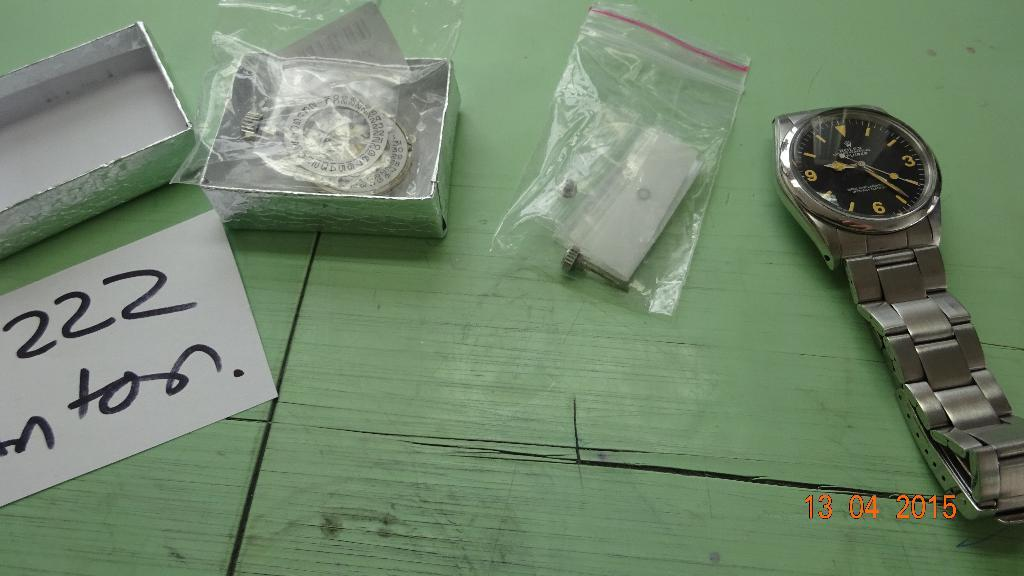<image>
Relay a brief, clear account of the picture shown. A worn looking Rolex watch is laying on a green surface with a box and some baggies next to it. 